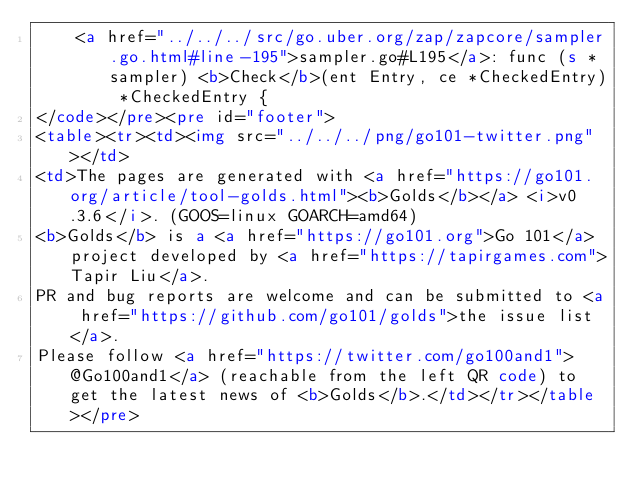Convert code to text. <code><loc_0><loc_0><loc_500><loc_500><_HTML_>		<a href="../../../src/go.uber.org/zap/zapcore/sampler.go.html#line-195">sampler.go#L195</a>: func (s *sampler) <b>Check</b>(ent Entry, ce *CheckedEntry) *CheckedEntry {
</code></pre><pre id="footer">
<table><tr><td><img src="../../../png/go101-twitter.png"></td>
<td>The pages are generated with <a href="https://go101.org/article/tool-golds.html"><b>Golds</b></a> <i>v0.3.6</i>. (GOOS=linux GOARCH=amd64)
<b>Golds</b> is a <a href="https://go101.org">Go 101</a> project developed by <a href="https://tapirgames.com">Tapir Liu</a>.
PR and bug reports are welcome and can be submitted to <a href="https://github.com/go101/golds">the issue list</a>.
Please follow <a href="https://twitter.com/go100and1">@Go100and1</a> (reachable from the left QR code) to get the latest news of <b>Golds</b>.</td></tr></table></pre></code> 